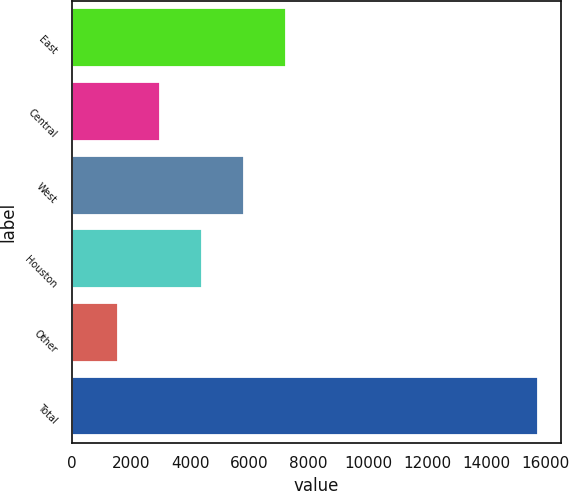Convert chart to OTSL. <chart><loc_0><loc_0><loc_500><loc_500><bar_chart><fcel>East<fcel>Central<fcel>West<fcel>Houston<fcel>Other<fcel>Total<nl><fcel>7235.4<fcel>2985.6<fcel>5818.8<fcel>4402.2<fcel>1569<fcel>15735<nl></chart> 